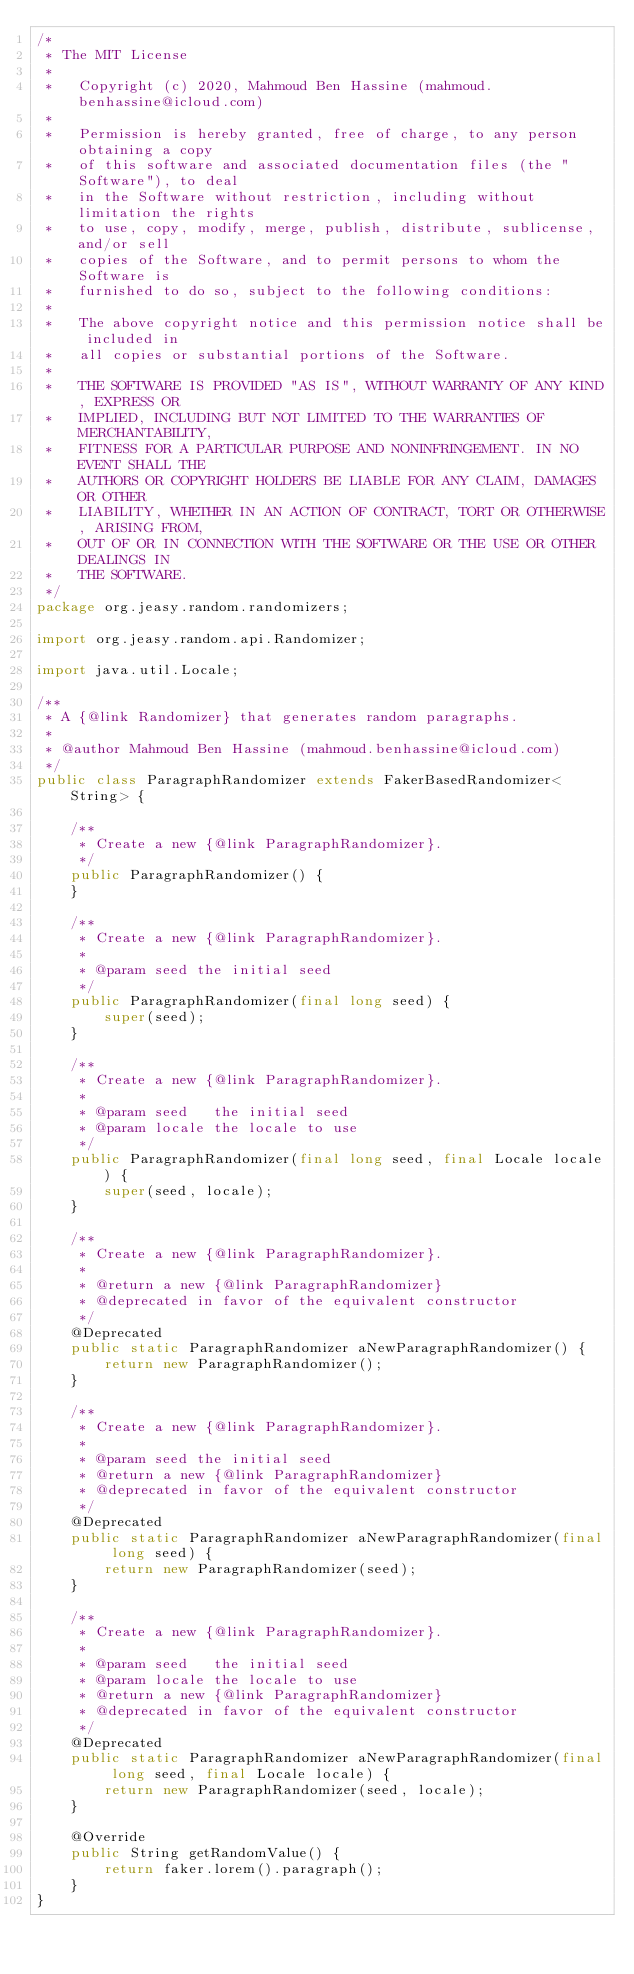<code> <loc_0><loc_0><loc_500><loc_500><_Java_>/*
 * The MIT License
 *
 *   Copyright (c) 2020, Mahmoud Ben Hassine (mahmoud.benhassine@icloud.com)
 *
 *   Permission is hereby granted, free of charge, to any person obtaining a copy
 *   of this software and associated documentation files (the "Software"), to deal
 *   in the Software without restriction, including without limitation the rights
 *   to use, copy, modify, merge, publish, distribute, sublicense, and/or sell
 *   copies of the Software, and to permit persons to whom the Software is
 *   furnished to do so, subject to the following conditions:
 *
 *   The above copyright notice and this permission notice shall be included in
 *   all copies or substantial portions of the Software.
 *
 *   THE SOFTWARE IS PROVIDED "AS IS", WITHOUT WARRANTY OF ANY KIND, EXPRESS OR
 *   IMPLIED, INCLUDING BUT NOT LIMITED TO THE WARRANTIES OF MERCHANTABILITY,
 *   FITNESS FOR A PARTICULAR PURPOSE AND NONINFRINGEMENT. IN NO EVENT SHALL THE
 *   AUTHORS OR COPYRIGHT HOLDERS BE LIABLE FOR ANY CLAIM, DAMAGES OR OTHER
 *   LIABILITY, WHETHER IN AN ACTION OF CONTRACT, TORT OR OTHERWISE, ARISING FROM,
 *   OUT OF OR IN CONNECTION WITH THE SOFTWARE OR THE USE OR OTHER DEALINGS IN
 *   THE SOFTWARE.
 */
package org.jeasy.random.randomizers;

import org.jeasy.random.api.Randomizer;

import java.util.Locale;

/**
 * A {@link Randomizer} that generates random paragraphs.
 *
 * @author Mahmoud Ben Hassine (mahmoud.benhassine@icloud.com)
 */
public class ParagraphRandomizer extends FakerBasedRandomizer<String> {

    /**
     * Create a new {@link ParagraphRandomizer}.
     */
    public ParagraphRandomizer() {
    }

    /**
     * Create a new {@link ParagraphRandomizer}.
     *
     * @param seed the initial seed
     */
    public ParagraphRandomizer(final long seed) {
        super(seed);
    }

    /**
     * Create a new {@link ParagraphRandomizer}.
     *
     * @param seed   the initial seed
     * @param locale the locale to use
     */
    public ParagraphRandomizer(final long seed, final Locale locale) {
        super(seed, locale);
    }

    /**
     * Create a new {@link ParagraphRandomizer}.
     *
     * @return a new {@link ParagraphRandomizer}
     * @deprecated in favor of the equivalent constructor
     */
    @Deprecated
    public static ParagraphRandomizer aNewParagraphRandomizer() {
        return new ParagraphRandomizer();
    }

    /**
     * Create a new {@link ParagraphRandomizer}.
     *
     * @param seed the initial seed
     * @return a new {@link ParagraphRandomizer}
     * @deprecated in favor of the equivalent constructor
     */
    @Deprecated
    public static ParagraphRandomizer aNewParagraphRandomizer(final long seed) {
        return new ParagraphRandomizer(seed);
    }

    /**
     * Create a new {@link ParagraphRandomizer}.
     *
     * @param seed   the initial seed
     * @param locale the locale to use
     * @return a new {@link ParagraphRandomizer}
     * @deprecated in favor of the equivalent constructor
     */
    @Deprecated
    public static ParagraphRandomizer aNewParagraphRandomizer(final long seed, final Locale locale) {
        return new ParagraphRandomizer(seed, locale);
    }

    @Override
    public String getRandomValue() {
        return faker.lorem().paragraph();
    }
}
</code> 